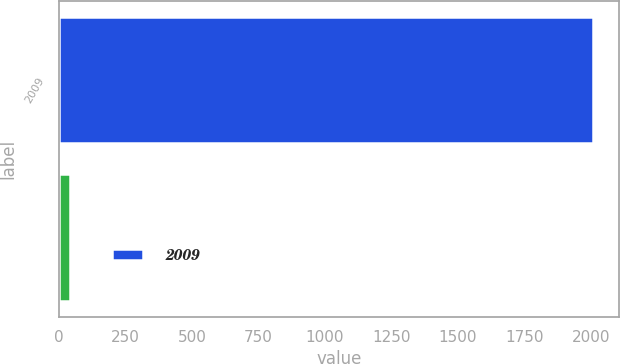Convert chart to OTSL. <chart><loc_0><loc_0><loc_500><loc_500><bar_chart><fcel>2009<fcel>Unnamed: 1<nl><fcel>2007<fcel>43<nl></chart> 